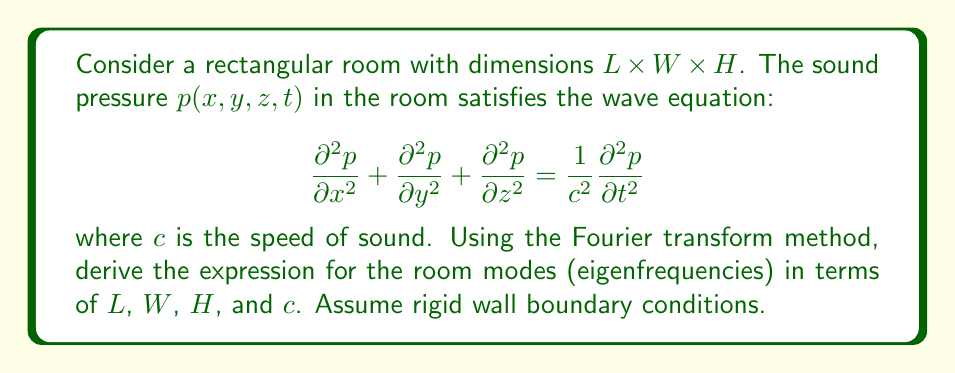Show me your answer to this math problem. 1) First, we apply the Fourier transform to the wave equation with respect to time:

   $$\frac{\partial^2 \hat{p}}{\partial x^2} + \frac{\partial^2 \hat{p}}{\partial y^2} + \frac{\partial^2 \hat{p}}{\partial z^2} + k^2\hat{p} = 0$$

   where $k = \omega/c$ is the wave number and $\omega$ is the angular frequency.

2) We assume a solution of the form:

   $$\hat{p}(x,y,z) = X(x)Y(y)Z(z)$$

3) Substituting this into the transformed wave equation and separating variables:

   $$\frac{1}{X}\frac{d^2X}{dx^2} + \frac{1}{Y}\frac{d^2Y}{dy^2} + \frac{1}{Z}\frac{d^2Z}{dz^2} + k^2 = 0$$

4) This leads to three separate equations:

   $$\frac{d^2X}{dx^2} + k_x^2X = 0$$
   $$\frac{d^2Y}{dy^2} + k_y^2Y = 0$$
   $$\frac{d^2Z}{dz^2} + k_z^2Z = 0$$

   where $k_x^2 + k_y^2 + k_z^2 = k^2$

5) The rigid wall boundary conditions imply:

   $$\frac{dX}{dx} = 0 \text{ at } x = 0 \text{ and } x = L$$
   $$\frac{dY}{dy} = 0 \text{ at } y = 0 \text{ and } y = W$$
   $$\frac{dZ}{dz} = 0 \text{ at } z = 0 \text{ and } z = H$$

6) The solutions satisfying these conditions are:

   $$X(x) = \cos(k_x x), \quad k_x = \frac{n_x\pi}{L}, \quad n_x = 0,1,2,...$$
   $$Y(y) = \cos(k_y y), \quad k_y = \frac{n_y\pi}{W}, \quad n_y = 0,1,2,...$$
   $$Z(z) = \cos(k_z z), \quad k_z = \frac{n_z\pi}{H}, \quad n_z = 0,1,2,...$$

7) Substituting these back into the relation $k_x^2 + k_y^2 + k_z^2 = k^2 = \omega^2/c^2$:

   $$\left(\frac{n_x\pi}{L}\right)^2 + \left(\frac{n_y\pi}{W}\right)^2 + \left(\frac{n_z\pi}{H}\right)^2 = \frac{\omega^2}{c^2}$$

8) Solving for $\omega$, we get the expression for the room modes:

   $$\omega_{n_x,n_y,n_z} = c\pi\sqrt{\left(\frac{n_x}{L}\right)^2 + \left(\frac{n_y}{W}\right)^2 + \left(\frac{n_z}{H}\right)^2}$$

9) Converting to frequency $f = \omega/(2\pi)$, we obtain the final expression:

   $$f_{n_x,n_y,n_z} = \frac{c}{2}\sqrt{\left(\frac{n_x}{L}\right)^2 + \left(\frac{n_y}{W}\right)^2 + \left(\frac{n_z}{H}\right)^2}$$
Answer: $$f_{n_x,n_y,n_z} = \frac{c}{2}\sqrt{\left(\frac{n_x}{L}\right)^2 + \left(\frac{n_y}{W}\right)^2 + \left(\frac{n_z}{H}\right)^2}$$ 